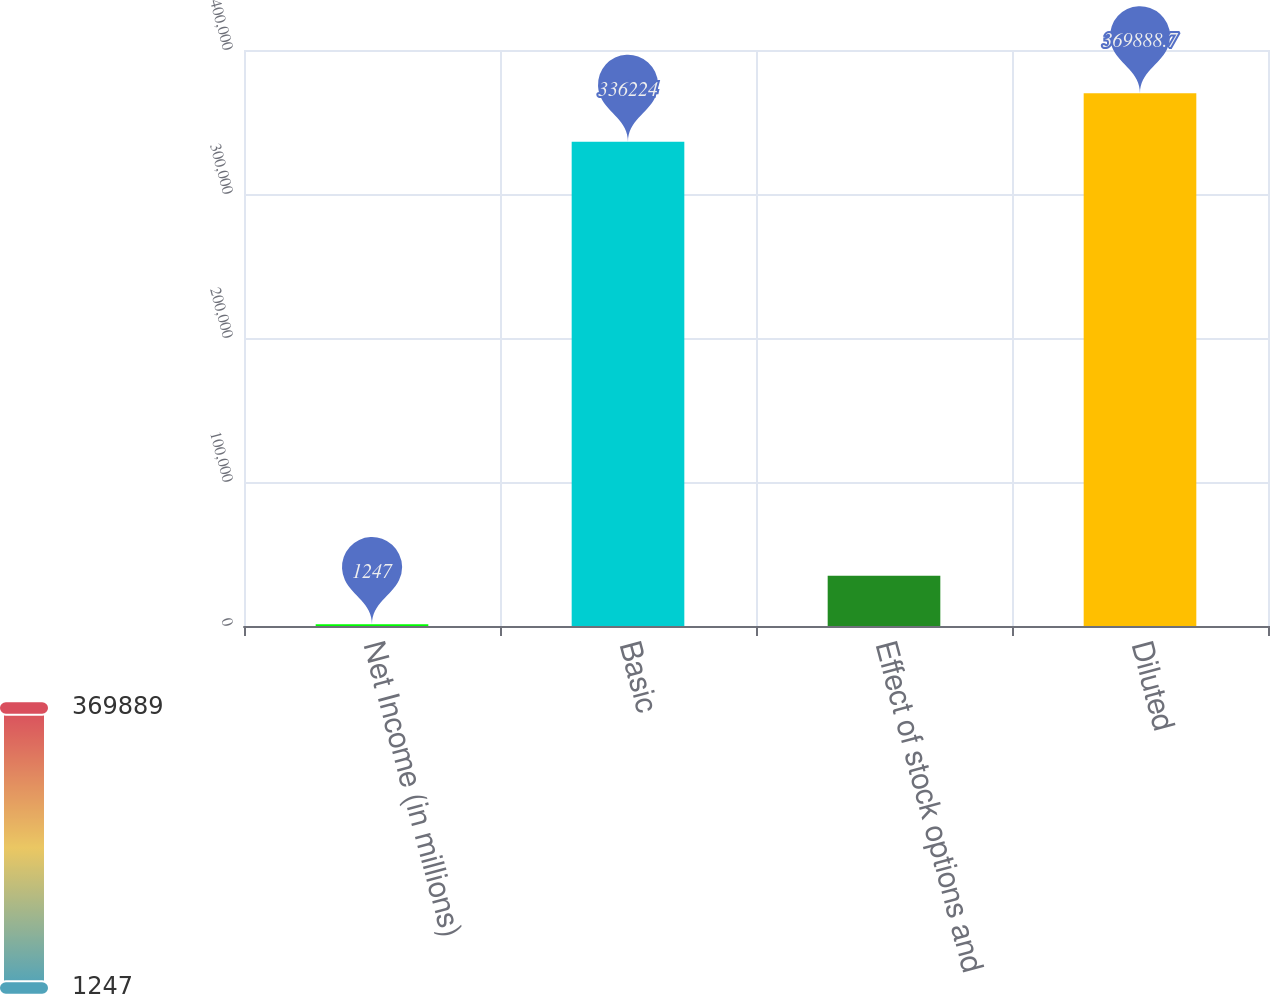Convert chart. <chart><loc_0><loc_0><loc_500><loc_500><bar_chart><fcel>Net Income (in millions)<fcel>Basic<fcel>Effect of stock options and<fcel>Diluted<nl><fcel>1247<fcel>336224<fcel>34911.7<fcel>369889<nl></chart> 